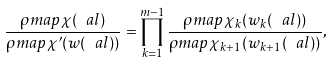<formula> <loc_0><loc_0><loc_500><loc_500>\frac { \rho m a p \chi ( \ a l ) } { \rho m a p { \chi ^ { \prime } } ( w ( \ a l ) ) } = \prod _ { k = 1 } ^ { m - 1 } \frac { \rho m a p { \chi _ { k } } ( w _ { k } ( \ a l ) ) } { \rho m a p { \chi _ { k + 1 } } ( w _ { k + 1 } ( \ a l ) ) } ,</formula> 